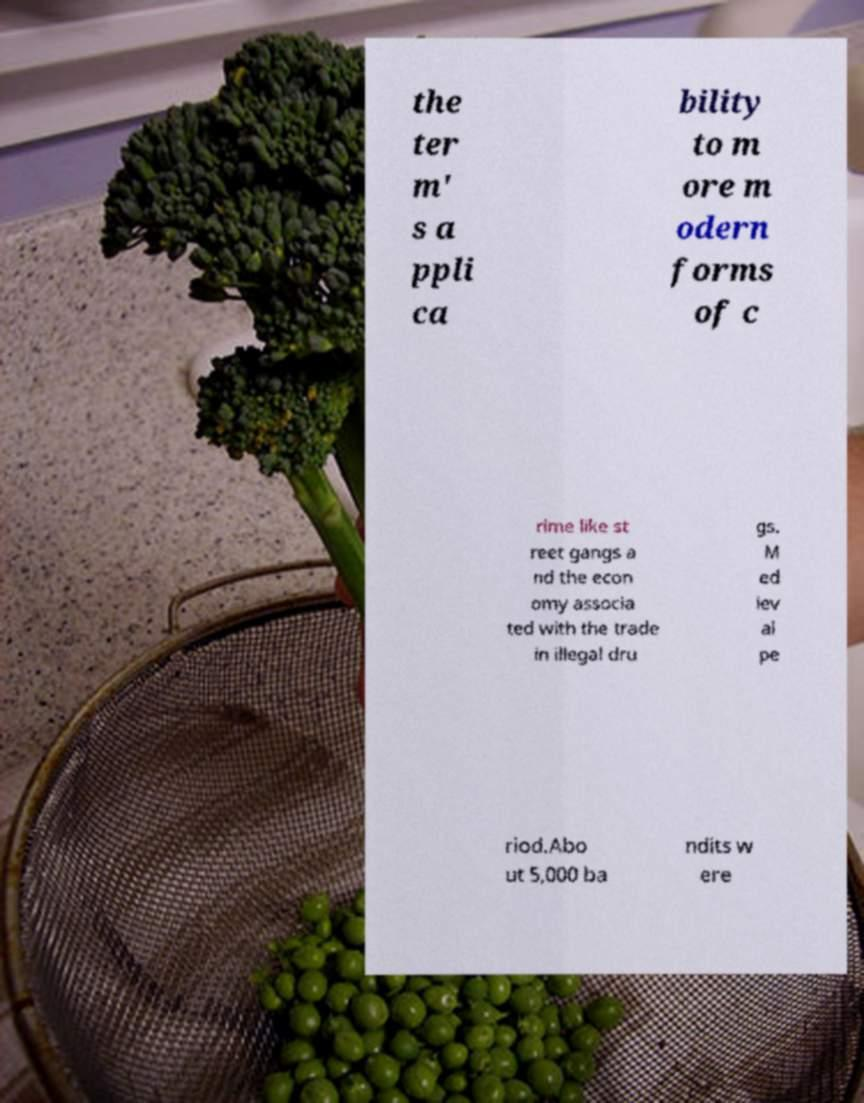I need the written content from this picture converted into text. Can you do that? the ter m' s a ppli ca bility to m ore m odern forms of c rime like st reet gangs a nd the econ omy associa ted with the trade in illegal dru gs. M ed iev al pe riod.Abo ut 5,000 ba ndits w ere 